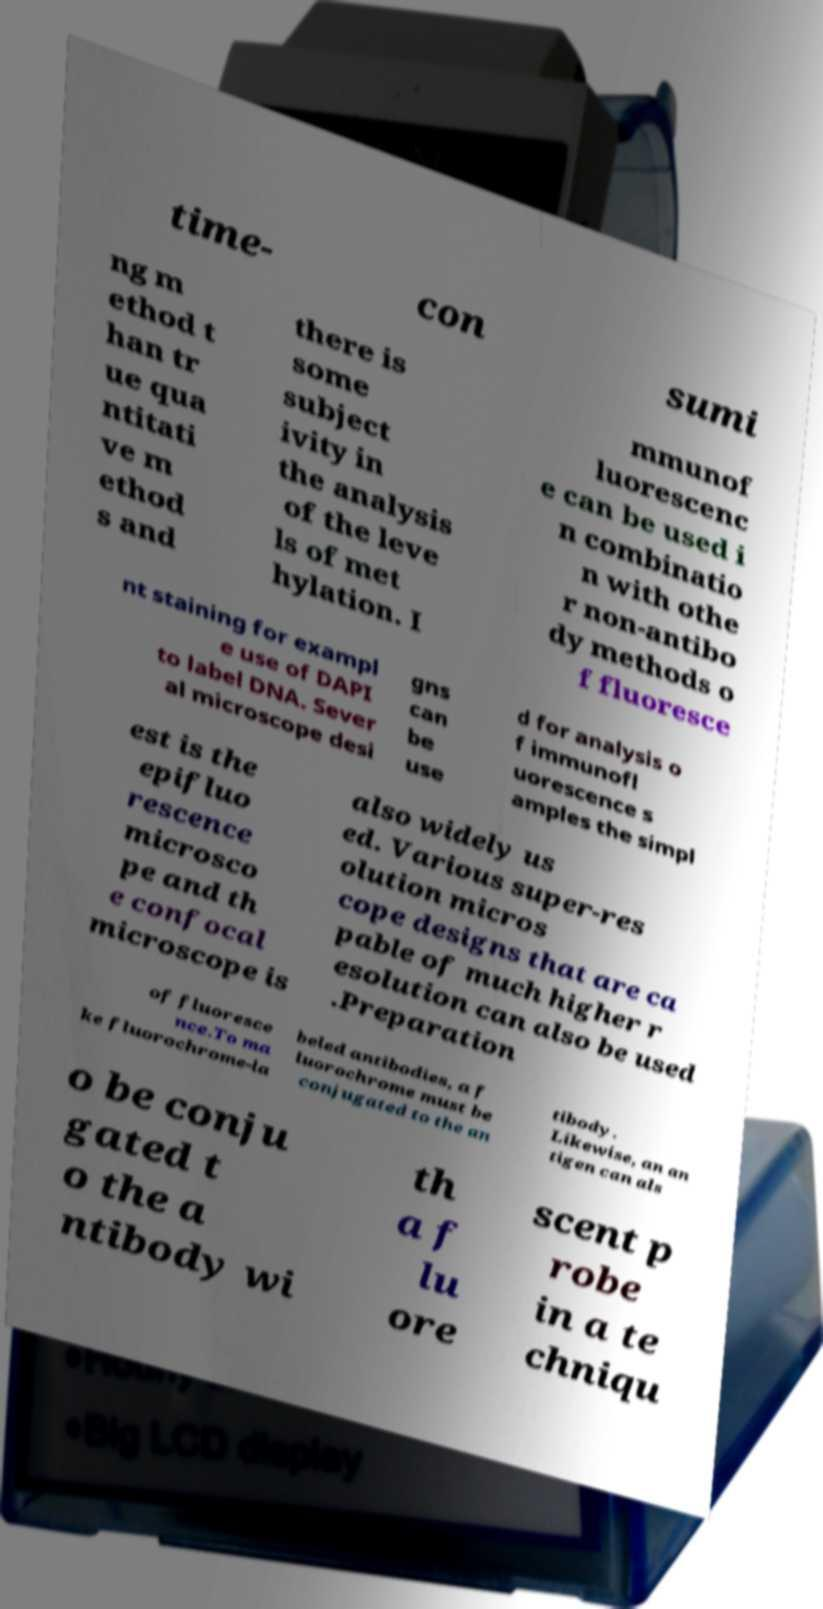Could you assist in decoding the text presented in this image and type it out clearly? time- con sumi ng m ethod t han tr ue qua ntitati ve m ethod s and there is some subject ivity in the analysis of the leve ls of met hylation. I mmunof luorescenc e can be used i n combinatio n with othe r non-antibo dy methods o f fluoresce nt staining for exampl e use of DAPI to label DNA. Sever al microscope desi gns can be use d for analysis o f immunofl uorescence s amples the simpl est is the epifluo rescence microsco pe and th e confocal microscope is also widely us ed. Various super-res olution micros cope designs that are ca pable of much higher r esolution can also be used .Preparation of fluoresce nce.To ma ke fluorochrome-la beled antibodies, a f luorochrome must be conjugated to the an tibody. Likewise, an an tigen can als o be conju gated t o the a ntibody wi th a f lu ore scent p robe in a te chniqu 